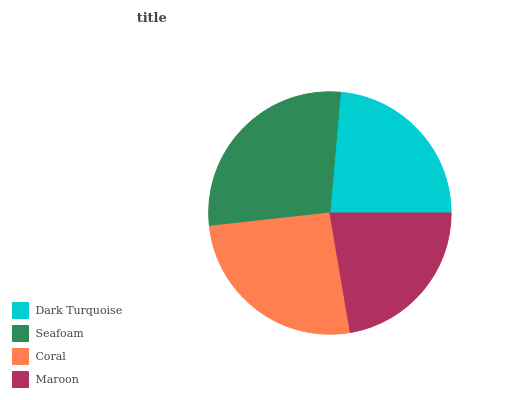Is Maroon the minimum?
Answer yes or no. Yes. Is Seafoam the maximum?
Answer yes or no. Yes. Is Coral the minimum?
Answer yes or no. No. Is Coral the maximum?
Answer yes or no. No. Is Seafoam greater than Coral?
Answer yes or no. Yes. Is Coral less than Seafoam?
Answer yes or no. Yes. Is Coral greater than Seafoam?
Answer yes or no. No. Is Seafoam less than Coral?
Answer yes or no. No. Is Coral the high median?
Answer yes or no. Yes. Is Dark Turquoise the low median?
Answer yes or no. Yes. Is Maroon the high median?
Answer yes or no. No. Is Maroon the low median?
Answer yes or no. No. 